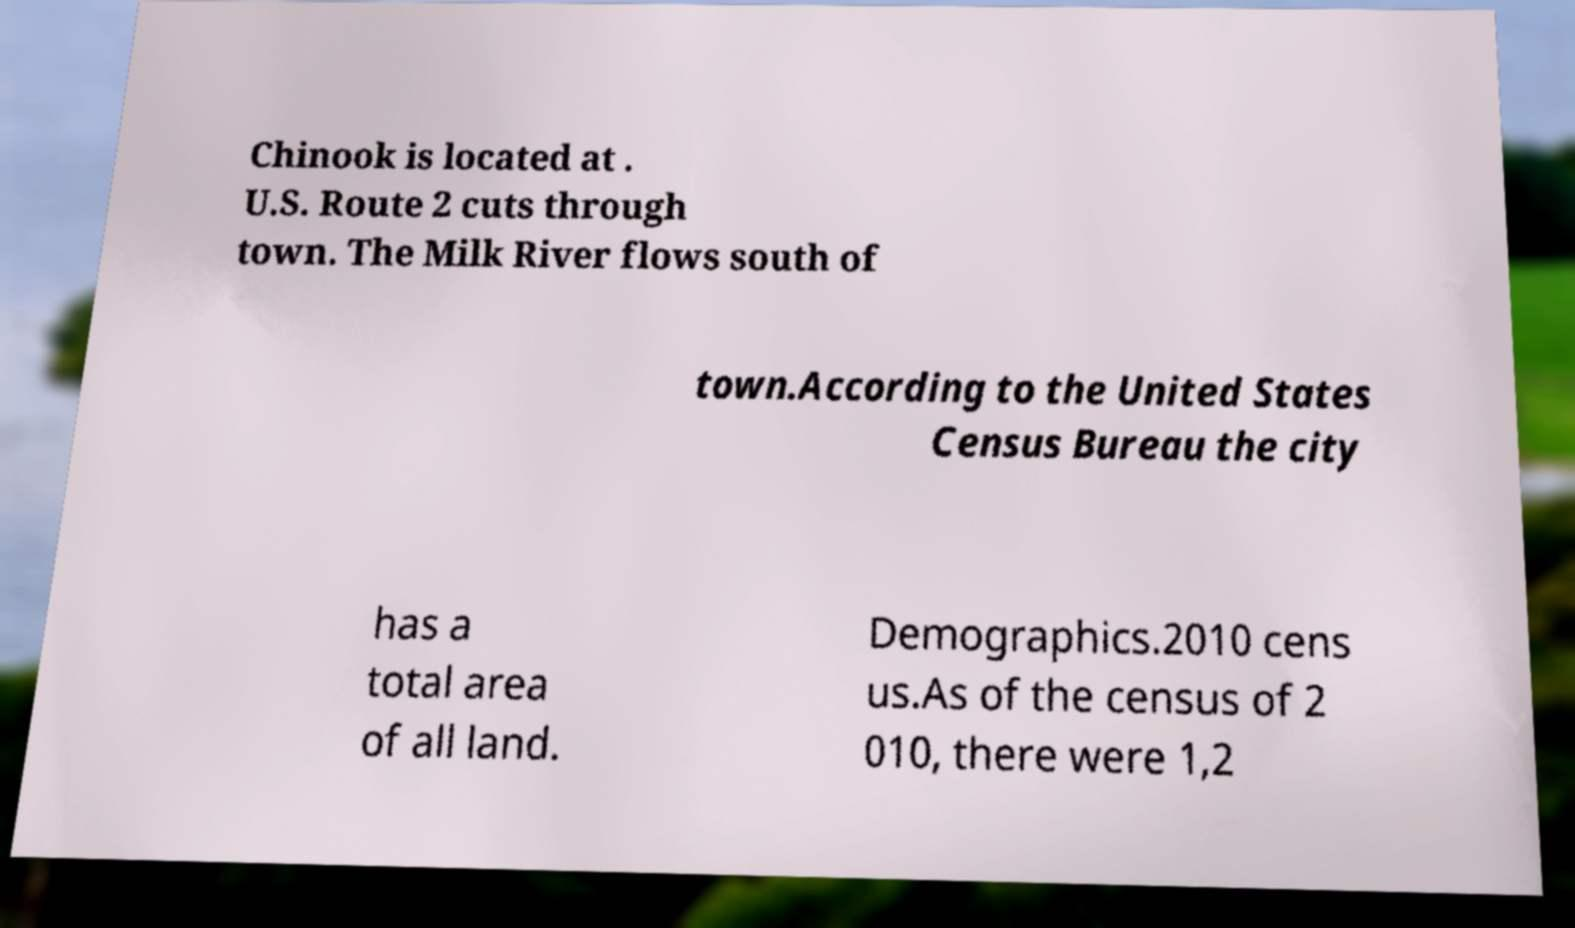Could you assist in decoding the text presented in this image and type it out clearly? Chinook is located at . U.S. Route 2 cuts through town. The Milk River flows south of town.According to the United States Census Bureau the city has a total area of all land. Demographics.2010 cens us.As of the census of 2 010, there were 1,2 